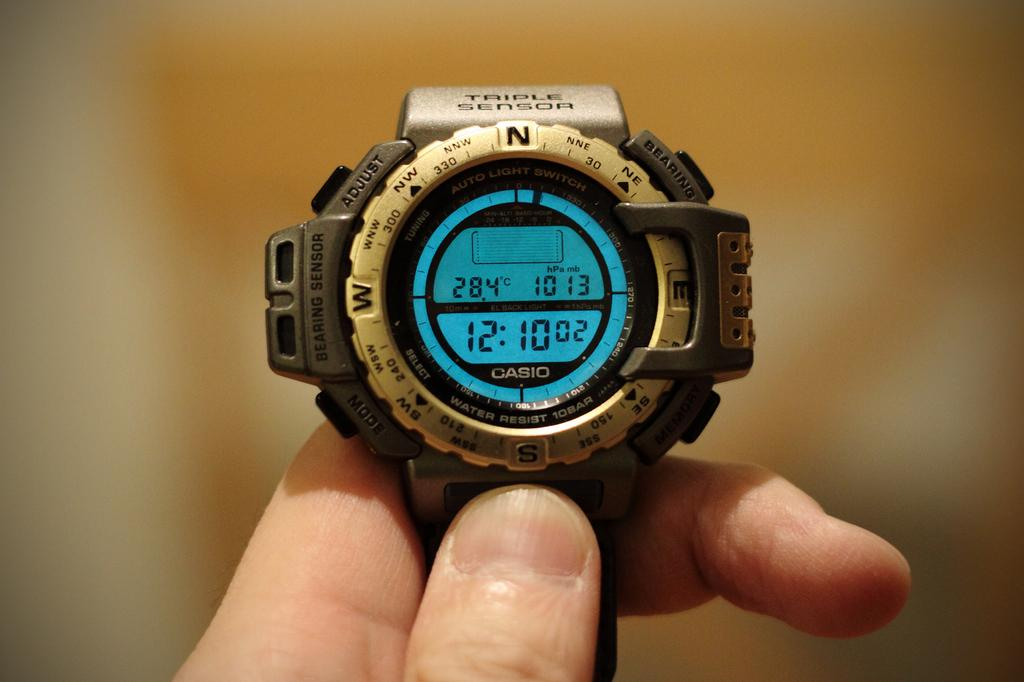<image>
Give a short and clear explanation of the subsequent image. The time "12:10" is shown on a casio watch. 